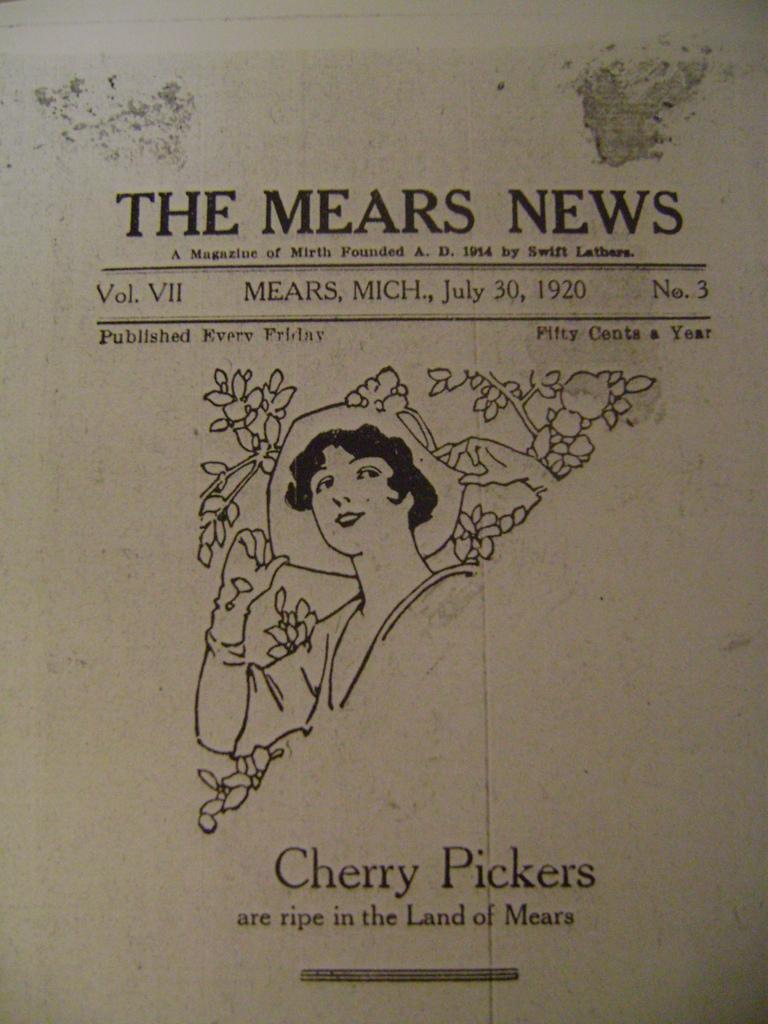Please provide a concise description of this image. In the center of the image we can see a paper and there is a lady in the center. At the top and bottom we can see text. 